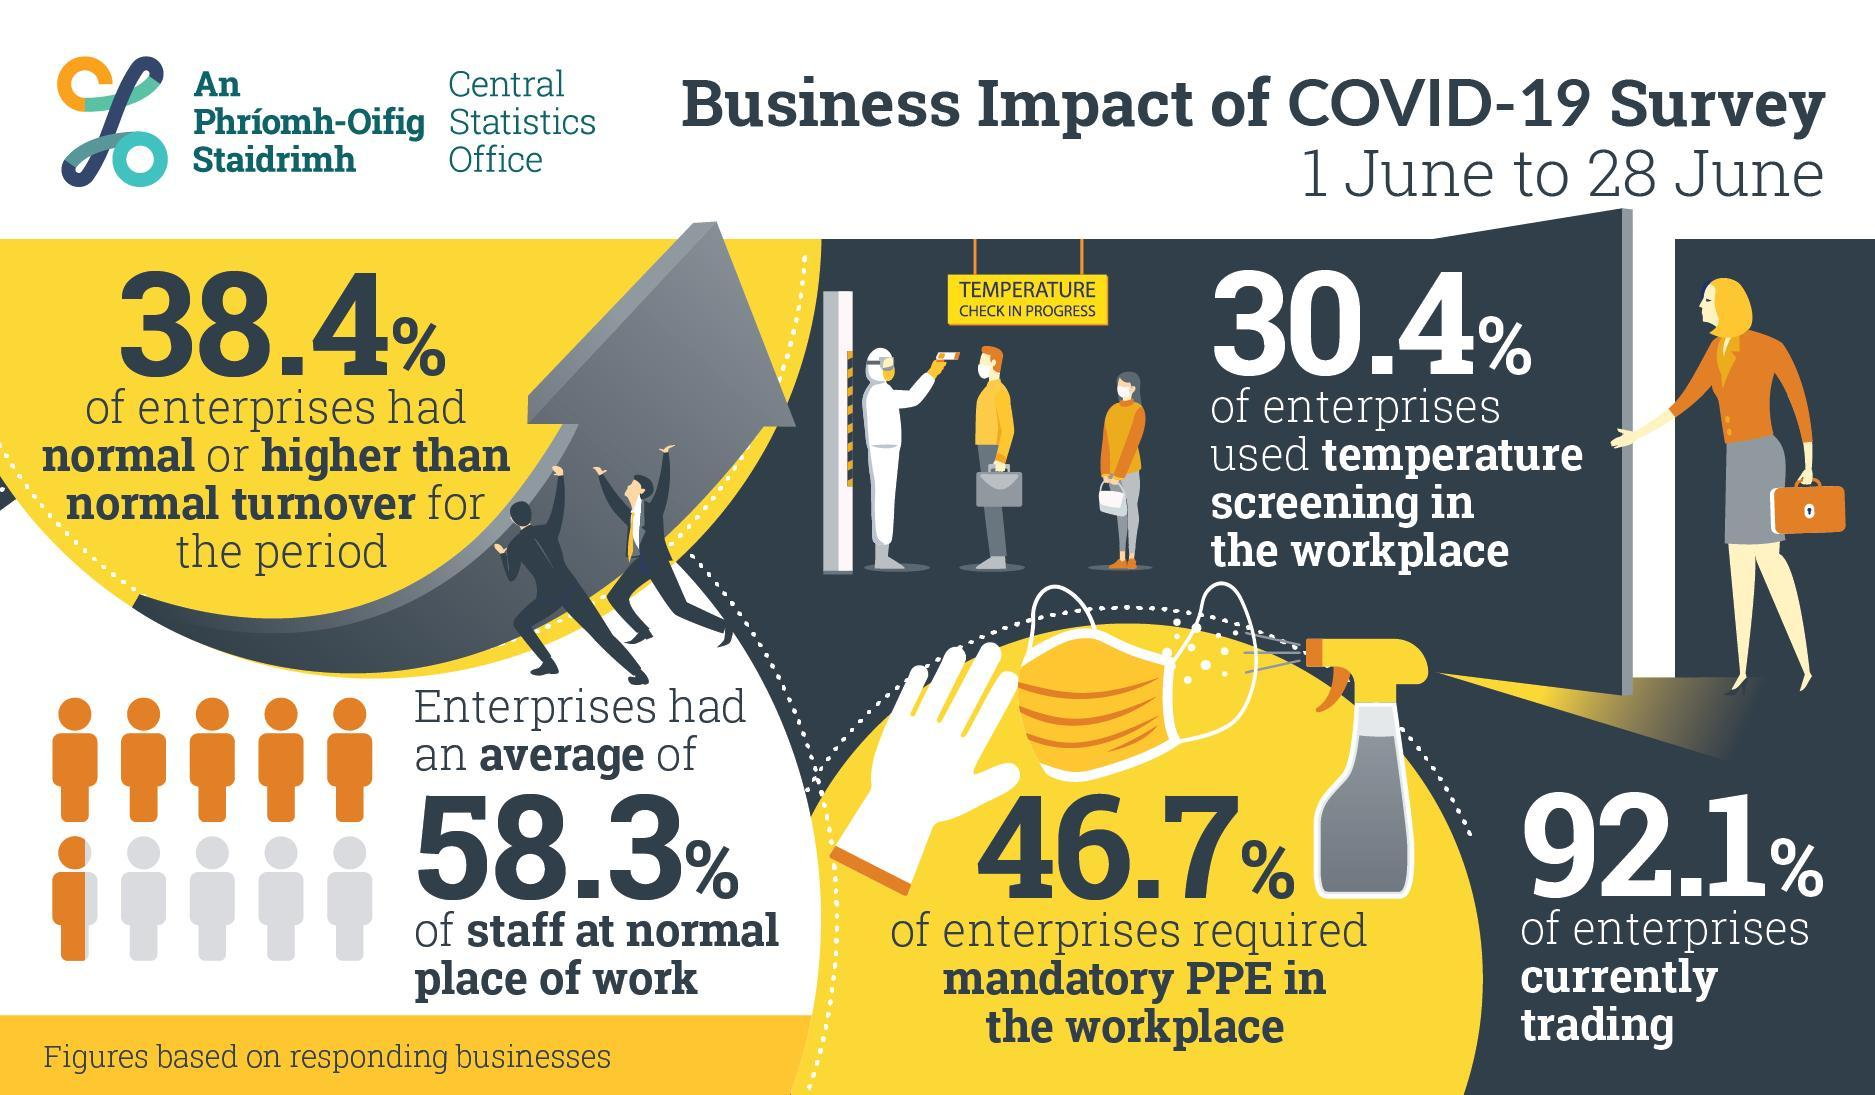What percent of the enterprises were not currently trading due to the impact of COVID-19 as per the Central Statistics Office Survey?
Answer the question with a short phrase. 7.9% What percent of the enterprises didn't use temperature screening in the workplace as per the Central Statistics Office Survey? 69.6% What percent of the enterprises required mandatory PPE in the workplace due to the impact of COVID-19 as per the Central Statistics Office Survey? 46.7% 